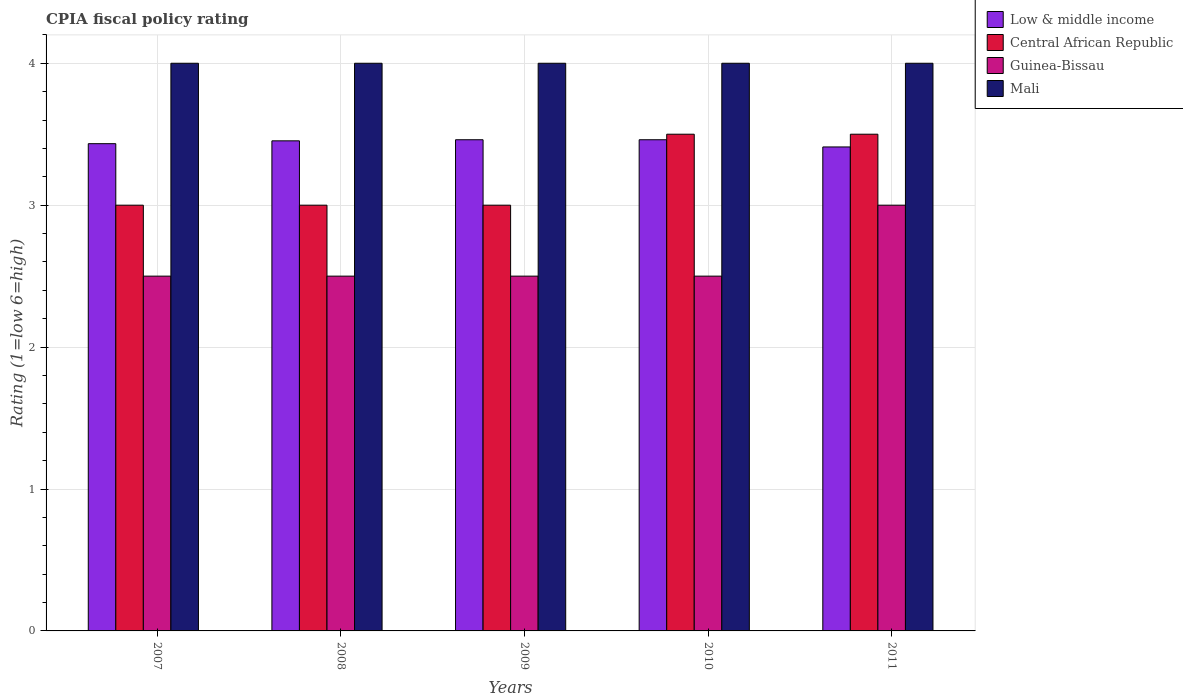How many different coloured bars are there?
Make the answer very short. 4. How many groups of bars are there?
Offer a terse response. 5. How many bars are there on the 4th tick from the left?
Offer a very short reply. 4. How many bars are there on the 2nd tick from the right?
Offer a terse response. 4. What is the CPIA rating in Mali in 2009?
Provide a succinct answer. 4. Across all years, what is the maximum CPIA rating in Mali?
Ensure brevity in your answer.  4. What is the total CPIA rating in Guinea-Bissau in the graph?
Provide a short and direct response. 13. What is the difference between the CPIA rating in Low & middle income in 2007 and that in 2008?
Ensure brevity in your answer.  -0.02. What is the difference between the CPIA rating in Guinea-Bissau in 2011 and the CPIA rating in Low & middle income in 2009?
Ensure brevity in your answer.  -0.46. What is the average CPIA rating in Guinea-Bissau per year?
Offer a very short reply. 2.6. In the year 2009, what is the difference between the CPIA rating in Low & middle income and CPIA rating in Central African Republic?
Ensure brevity in your answer.  0.46. In how many years, is the CPIA rating in Guinea-Bissau greater than 0.6000000000000001?
Ensure brevity in your answer.  5. What is the ratio of the CPIA rating in Central African Republic in 2009 to that in 2011?
Your answer should be compact. 0.86. Is the difference between the CPIA rating in Low & middle income in 2009 and 2010 greater than the difference between the CPIA rating in Central African Republic in 2009 and 2010?
Make the answer very short. Yes. In how many years, is the CPIA rating in Mali greater than the average CPIA rating in Mali taken over all years?
Your response must be concise. 0. Is the sum of the CPIA rating in Central African Republic in 2008 and 2011 greater than the maximum CPIA rating in Guinea-Bissau across all years?
Offer a terse response. Yes. Is it the case that in every year, the sum of the CPIA rating in Low & middle income and CPIA rating in Guinea-Bissau is greater than the sum of CPIA rating in Central African Republic and CPIA rating in Mali?
Provide a short and direct response. No. What does the 4th bar from the right in 2011 represents?
Give a very brief answer. Low & middle income. How many bars are there?
Provide a succinct answer. 20. Are all the bars in the graph horizontal?
Keep it short and to the point. No. How many years are there in the graph?
Keep it short and to the point. 5. Does the graph contain any zero values?
Provide a short and direct response. No. Does the graph contain grids?
Keep it short and to the point. Yes. Where does the legend appear in the graph?
Offer a terse response. Top right. What is the title of the graph?
Offer a terse response. CPIA fiscal policy rating. Does "Congo (Democratic)" appear as one of the legend labels in the graph?
Provide a succinct answer. No. What is the label or title of the Y-axis?
Make the answer very short. Rating (1=low 6=high). What is the Rating (1=low 6=high) of Low & middle income in 2007?
Ensure brevity in your answer.  3.43. What is the Rating (1=low 6=high) in Mali in 2007?
Your answer should be compact. 4. What is the Rating (1=low 6=high) of Low & middle income in 2008?
Your response must be concise. 3.45. What is the Rating (1=low 6=high) of Guinea-Bissau in 2008?
Keep it short and to the point. 2.5. What is the Rating (1=low 6=high) in Mali in 2008?
Provide a succinct answer. 4. What is the Rating (1=low 6=high) in Low & middle income in 2009?
Ensure brevity in your answer.  3.46. What is the Rating (1=low 6=high) in Central African Republic in 2009?
Make the answer very short. 3. What is the Rating (1=low 6=high) of Guinea-Bissau in 2009?
Your answer should be compact. 2.5. What is the Rating (1=low 6=high) of Low & middle income in 2010?
Provide a short and direct response. 3.46. What is the Rating (1=low 6=high) of Guinea-Bissau in 2010?
Your response must be concise. 2.5. What is the Rating (1=low 6=high) in Low & middle income in 2011?
Offer a very short reply. 3.41. Across all years, what is the maximum Rating (1=low 6=high) of Low & middle income?
Provide a short and direct response. 3.46. Across all years, what is the maximum Rating (1=low 6=high) in Guinea-Bissau?
Ensure brevity in your answer.  3. Across all years, what is the maximum Rating (1=low 6=high) of Mali?
Your response must be concise. 4. Across all years, what is the minimum Rating (1=low 6=high) of Low & middle income?
Ensure brevity in your answer.  3.41. Across all years, what is the minimum Rating (1=low 6=high) in Guinea-Bissau?
Your response must be concise. 2.5. What is the total Rating (1=low 6=high) of Low & middle income in the graph?
Your answer should be compact. 17.22. What is the total Rating (1=low 6=high) in Mali in the graph?
Provide a short and direct response. 20. What is the difference between the Rating (1=low 6=high) of Low & middle income in 2007 and that in 2008?
Provide a succinct answer. -0.02. What is the difference between the Rating (1=low 6=high) in Mali in 2007 and that in 2008?
Provide a short and direct response. 0. What is the difference between the Rating (1=low 6=high) of Low & middle income in 2007 and that in 2009?
Your answer should be compact. -0.03. What is the difference between the Rating (1=low 6=high) in Guinea-Bissau in 2007 and that in 2009?
Your answer should be compact. 0. What is the difference between the Rating (1=low 6=high) of Low & middle income in 2007 and that in 2010?
Make the answer very short. -0.03. What is the difference between the Rating (1=low 6=high) of Central African Republic in 2007 and that in 2010?
Your answer should be compact. -0.5. What is the difference between the Rating (1=low 6=high) of Mali in 2007 and that in 2010?
Your answer should be compact. 0. What is the difference between the Rating (1=low 6=high) of Low & middle income in 2007 and that in 2011?
Your answer should be compact. 0.02. What is the difference between the Rating (1=low 6=high) in Central African Republic in 2007 and that in 2011?
Ensure brevity in your answer.  -0.5. What is the difference between the Rating (1=low 6=high) of Guinea-Bissau in 2007 and that in 2011?
Keep it short and to the point. -0.5. What is the difference between the Rating (1=low 6=high) in Low & middle income in 2008 and that in 2009?
Provide a short and direct response. -0.01. What is the difference between the Rating (1=low 6=high) of Central African Republic in 2008 and that in 2009?
Offer a terse response. 0. What is the difference between the Rating (1=low 6=high) of Low & middle income in 2008 and that in 2010?
Offer a very short reply. -0.01. What is the difference between the Rating (1=low 6=high) of Central African Republic in 2008 and that in 2010?
Provide a short and direct response. -0.5. What is the difference between the Rating (1=low 6=high) in Guinea-Bissau in 2008 and that in 2010?
Make the answer very short. 0. What is the difference between the Rating (1=low 6=high) in Low & middle income in 2008 and that in 2011?
Keep it short and to the point. 0.04. What is the difference between the Rating (1=low 6=high) in Guinea-Bissau in 2008 and that in 2011?
Provide a succinct answer. -0.5. What is the difference between the Rating (1=low 6=high) in Central African Republic in 2009 and that in 2010?
Give a very brief answer. -0.5. What is the difference between the Rating (1=low 6=high) of Low & middle income in 2009 and that in 2011?
Offer a terse response. 0.05. What is the difference between the Rating (1=low 6=high) in Guinea-Bissau in 2009 and that in 2011?
Ensure brevity in your answer.  -0.5. What is the difference between the Rating (1=low 6=high) in Mali in 2009 and that in 2011?
Offer a very short reply. 0. What is the difference between the Rating (1=low 6=high) in Low & middle income in 2010 and that in 2011?
Provide a short and direct response. 0.05. What is the difference between the Rating (1=low 6=high) in Central African Republic in 2010 and that in 2011?
Your answer should be compact. 0. What is the difference between the Rating (1=low 6=high) of Guinea-Bissau in 2010 and that in 2011?
Your answer should be compact. -0.5. What is the difference between the Rating (1=low 6=high) of Low & middle income in 2007 and the Rating (1=low 6=high) of Central African Republic in 2008?
Your answer should be very brief. 0.43. What is the difference between the Rating (1=low 6=high) of Low & middle income in 2007 and the Rating (1=low 6=high) of Guinea-Bissau in 2008?
Keep it short and to the point. 0.93. What is the difference between the Rating (1=low 6=high) in Low & middle income in 2007 and the Rating (1=low 6=high) in Mali in 2008?
Your response must be concise. -0.57. What is the difference between the Rating (1=low 6=high) of Central African Republic in 2007 and the Rating (1=low 6=high) of Mali in 2008?
Provide a short and direct response. -1. What is the difference between the Rating (1=low 6=high) in Guinea-Bissau in 2007 and the Rating (1=low 6=high) in Mali in 2008?
Give a very brief answer. -1.5. What is the difference between the Rating (1=low 6=high) of Low & middle income in 2007 and the Rating (1=low 6=high) of Central African Republic in 2009?
Provide a short and direct response. 0.43. What is the difference between the Rating (1=low 6=high) in Low & middle income in 2007 and the Rating (1=low 6=high) in Mali in 2009?
Provide a short and direct response. -0.57. What is the difference between the Rating (1=low 6=high) in Central African Republic in 2007 and the Rating (1=low 6=high) in Mali in 2009?
Ensure brevity in your answer.  -1. What is the difference between the Rating (1=low 6=high) in Low & middle income in 2007 and the Rating (1=low 6=high) in Central African Republic in 2010?
Give a very brief answer. -0.07. What is the difference between the Rating (1=low 6=high) of Low & middle income in 2007 and the Rating (1=low 6=high) of Guinea-Bissau in 2010?
Your response must be concise. 0.93. What is the difference between the Rating (1=low 6=high) in Low & middle income in 2007 and the Rating (1=low 6=high) in Mali in 2010?
Your answer should be very brief. -0.57. What is the difference between the Rating (1=low 6=high) of Central African Republic in 2007 and the Rating (1=low 6=high) of Guinea-Bissau in 2010?
Provide a succinct answer. 0.5. What is the difference between the Rating (1=low 6=high) in Guinea-Bissau in 2007 and the Rating (1=low 6=high) in Mali in 2010?
Make the answer very short. -1.5. What is the difference between the Rating (1=low 6=high) in Low & middle income in 2007 and the Rating (1=low 6=high) in Central African Republic in 2011?
Make the answer very short. -0.07. What is the difference between the Rating (1=low 6=high) in Low & middle income in 2007 and the Rating (1=low 6=high) in Guinea-Bissau in 2011?
Your answer should be very brief. 0.43. What is the difference between the Rating (1=low 6=high) of Low & middle income in 2007 and the Rating (1=low 6=high) of Mali in 2011?
Provide a short and direct response. -0.57. What is the difference between the Rating (1=low 6=high) of Central African Republic in 2007 and the Rating (1=low 6=high) of Mali in 2011?
Ensure brevity in your answer.  -1. What is the difference between the Rating (1=low 6=high) in Guinea-Bissau in 2007 and the Rating (1=low 6=high) in Mali in 2011?
Make the answer very short. -1.5. What is the difference between the Rating (1=low 6=high) in Low & middle income in 2008 and the Rating (1=low 6=high) in Central African Republic in 2009?
Your answer should be compact. 0.45. What is the difference between the Rating (1=low 6=high) of Low & middle income in 2008 and the Rating (1=low 6=high) of Guinea-Bissau in 2009?
Your response must be concise. 0.95. What is the difference between the Rating (1=low 6=high) in Low & middle income in 2008 and the Rating (1=low 6=high) in Mali in 2009?
Provide a succinct answer. -0.55. What is the difference between the Rating (1=low 6=high) in Central African Republic in 2008 and the Rating (1=low 6=high) in Mali in 2009?
Ensure brevity in your answer.  -1. What is the difference between the Rating (1=low 6=high) in Guinea-Bissau in 2008 and the Rating (1=low 6=high) in Mali in 2009?
Your answer should be compact. -1.5. What is the difference between the Rating (1=low 6=high) of Low & middle income in 2008 and the Rating (1=low 6=high) of Central African Republic in 2010?
Offer a terse response. -0.05. What is the difference between the Rating (1=low 6=high) of Low & middle income in 2008 and the Rating (1=low 6=high) of Guinea-Bissau in 2010?
Ensure brevity in your answer.  0.95. What is the difference between the Rating (1=low 6=high) of Low & middle income in 2008 and the Rating (1=low 6=high) of Mali in 2010?
Give a very brief answer. -0.55. What is the difference between the Rating (1=low 6=high) in Guinea-Bissau in 2008 and the Rating (1=low 6=high) in Mali in 2010?
Your answer should be very brief. -1.5. What is the difference between the Rating (1=low 6=high) in Low & middle income in 2008 and the Rating (1=low 6=high) in Central African Republic in 2011?
Keep it short and to the point. -0.05. What is the difference between the Rating (1=low 6=high) of Low & middle income in 2008 and the Rating (1=low 6=high) of Guinea-Bissau in 2011?
Ensure brevity in your answer.  0.45. What is the difference between the Rating (1=low 6=high) of Low & middle income in 2008 and the Rating (1=low 6=high) of Mali in 2011?
Provide a short and direct response. -0.55. What is the difference between the Rating (1=low 6=high) of Central African Republic in 2008 and the Rating (1=low 6=high) of Mali in 2011?
Your answer should be very brief. -1. What is the difference between the Rating (1=low 6=high) of Guinea-Bissau in 2008 and the Rating (1=low 6=high) of Mali in 2011?
Provide a short and direct response. -1.5. What is the difference between the Rating (1=low 6=high) in Low & middle income in 2009 and the Rating (1=low 6=high) in Central African Republic in 2010?
Your answer should be very brief. -0.04. What is the difference between the Rating (1=low 6=high) of Low & middle income in 2009 and the Rating (1=low 6=high) of Guinea-Bissau in 2010?
Your answer should be very brief. 0.96. What is the difference between the Rating (1=low 6=high) in Low & middle income in 2009 and the Rating (1=low 6=high) in Mali in 2010?
Your response must be concise. -0.54. What is the difference between the Rating (1=low 6=high) of Central African Republic in 2009 and the Rating (1=low 6=high) of Guinea-Bissau in 2010?
Provide a short and direct response. 0.5. What is the difference between the Rating (1=low 6=high) in Central African Republic in 2009 and the Rating (1=low 6=high) in Mali in 2010?
Offer a very short reply. -1. What is the difference between the Rating (1=low 6=high) of Guinea-Bissau in 2009 and the Rating (1=low 6=high) of Mali in 2010?
Give a very brief answer. -1.5. What is the difference between the Rating (1=low 6=high) in Low & middle income in 2009 and the Rating (1=low 6=high) in Central African Republic in 2011?
Give a very brief answer. -0.04. What is the difference between the Rating (1=low 6=high) in Low & middle income in 2009 and the Rating (1=low 6=high) in Guinea-Bissau in 2011?
Offer a very short reply. 0.46. What is the difference between the Rating (1=low 6=high) of Low & middle income in 2009 and the Rating (1=low 6=high) of Mali in 2011?
Provide a succinct answer. -0.54. What is the difference between the Rating (1=low 6=high) in Central African Republic in 2009 and the Rating (1=low 6=high) in Mali in 2011?
Ensure brevity in your answer.  -1. What is the difference between the Rating (1=low 6=high) of Guinea-Bissau in 2009 and the Rating (1=low 6=high) of Mali in 2011?
Make the answer very short. -1.5. What is the difference between the Rating (1=low 6=high) of Low & middle income in 2010 and the Rating (1=low 6=high) of Central African Republic in 2011?
Offer a terse response. -0.04. What is the difference between the Rating (1=low 6=high) in Low & middle income in 2010 and the Rating (1=low 6=high) in Guinea-Bissau in 2011?
Your answer should be compact. 0.46. What is the difference between the Rating (1=low 6=high) of Low & middle income in 2010 and the Rating (1=low 6=high) of Mali in 2011?
Your response must be concise. -0.54. What is the difference between the Rating (1=low 6=high) in Central African Republic in 2010 and the Rating (1=low 6=high) in Guinea-Bissau in 2011?
Provide a short and direct response. 0.5. What is the difference between the Rating (1=low 6=high) in Central African Republic in 2010 and the Rating (1=low 6=high) in Mali in 2011?
Your response must be concise. -0.5. What is the difference between the Rating (1=low 6=high) of Guinea-Bissau in 2010 and the Rating (1=low 6=high) of Mali in 2011?
Your response must be concise. -1.5. What is the average Rating (1=low 6=high) of Low & middle income per year?
Give a very brief answer. 3.44. What is the average Rating (1=low 6=high) of Central African Republic per year?
Provide a succinct answer. 3.2. What is the average Rating (1=low 6=high) in Mali per year?
Provide a short and direct response. 4. In the year 2007, what is the difference between the Rating (1=low 6=high) of Low & middle income and Rating (1=low 6=high) of Central African Republic?
Give a very brief answer. 0.43. In the year 2007, what is the difference between the Rating (1=low 6=high) of Low & middle income and Rating (1=low 6=high) of Mali?
Offer a terse response. -0.57. In the year 2007, what is the difference between the Rating (1=low 6=high) of Guinea-Bissau and Rating (1=low 6=high) of Mali?
Ensure brevity in your answer.  -1.5. In the year 2008, what is the difference between the Rating (1=low 6=high) in Low & middle income and Rating (1=low 6=high) in Central African Republic?
Provide a succinct answer. 0.45. In the year 2008, what is the difference between the Rating (1=low 6=high) in Low & middle income and Rating (1=low 6=high) in Guinea-Bissau?
Ensure brevity in your answer.  0.95. In the year 2008, what is the difference between the Rating (1=low 6=high) of Low & middle income and Rating (1=low 6=high) of Mali?
Provide a short and direct response. -0.55. In the year 2008, what is the difference between the Rating (1=low 6=high) in Guinea-Bissau and Rating (1=low 6=high) in Mali?
Make the answer very short. -1.5. In the year 2009, what is the difference between the Rating (1=low 6=high) in Low & middle income and Rating (1=low 6=high) in Central African Republic?
Offer a very short reply. 0.46. In the year 2009, what is the difference between the Rating (1=low 6=high) of Low & middle income and Rating (1=low 6=high) of Mali?
Make the answer very short. -0.54. In the year 2009, what is the difference between the Rating (1=low 6=high) of Central African Republic and Rating (1=low 6=high) of Guinea-Bissau?
Provide a short and direct response. 0.5. In the year 2009, what is the difference between the Rating (1=low 6=high) of Central African Republic and Rating (1=low 6=high) of Mali?
Make the answer very short. -1. In the year 2009, what is the difference between the Rating (1=low 6=high) in Guinea-Bissau and Rating (1=low 6=high) in Mali?
Offer a terse response. -1.5. In the year 2010, what is the difference between the Rating (1=low 6=high) of Low & middle income and Rating (1=low 6=high) of Central African Republic?
Keep it short and to the point. -0.04. In the year 2010, what is the difference between the Rating (1=low 6=high) of Low & middle income and Rating (1=low 6=high) of Mali?
Give a very brief answer. -0.54. In the year 2010, what is the difference between the Rating (1=low 6=high) in Central African Republic and Rating (1=low 6=high) in Guinea-Bissau?
Your answer should be compact. 1. In the year 2010, what is the difference between the Rating (1=low 6=high) in Guinea-Bissau and Rating (1=low 6=high) in Mali?
Ensure brevity in your answer.  -1.5. In the year 2011, what is the difference between the Rating (1=low 6=high) of Low & middle income and Rating (1=low 6=high) of Central African Republic?
Your answer should be very brief. -0.09. In the year 2011, what is the difference between the Rating (1=low 6=high) of Low & middle income and Rating (1=low 6=high) of Guinea-Bissau?
Give a very brief answer. 0.41. In the year 2011, what is the difference between the Rating (1=low 6=high) in Low & middle income and Rating (1=low 6=high) in Mali?
Give a very brief answer. -0.59. In the year 2011, what is the difference between the Rating (1=low 6=high) of Central African Republic and Rating (1=low 6=high) of Guinea-Bissau?
Your response must be concise. 0.5. In the year 2011, what is the difference between the Rating (1=low 6=high) in Guinea-Bissau and Rating (1=low 6=high) in Mali?
Your response must be concise. -1. What is the ratio of the Rating (1=low 6=high) of Low & middle income in 2007 to that in 2008?
Give a very brief answer. 0.99. What is the ratio of the Rating (1=low 6=high) in Guinea-Bissau in 2007 to that in 2008?
Offer a very short reply. 1. What is the ratio of the Rating (1=low 6=high) in Mali in 2007 to that in 2008?
Provide a succinct answer. 1. What is the ratio of the Rating (1=low 6=high) in Low & middle income in 2007 to that in 2010?
Provide a short and direct response. 0.99. What is the ratio of the Rating (1=low 6=high) of Central African Republic in 2007 to that in 2010?
Offer a very short reply. 0.86. What is the ratio of the Rating (1=low 6=high) of Mali in 2007 to that in 2010?
Provide a short and direct response. 1. What is the ratio of the Rating (1=low 6=high) in Low & middle income in 2007 to that in 2011?
Offer a terse response. 1.01. What is the ratio of the Rating (1=low 6=high) of Central African Republic in 2007 to that in 2011?
Provide a short and direct response. 0.86. What is the ratio of the Rating (1=low 6=high) of Guinea-Bissau in 2007 to that in 2011?
Ensure brevity in your answer.  0.83. What is the ratio of the Rating (1=low 6=high) in Central African Republic in 2008 to that in 2009?
Make the answer very short. 1. What is the ratio of the Rating (1=low 6=high) in Low & middle income in 2008 to that in 2010?
Provide a short and direct response. 1. What is the ratio of the Rating (1=low 6=high) in Mali in 2008 to that in 2010?
Give a very brief answer. 1. What is the ratio of the Rating (1=low 6=high) in Low & middle income in 2008 to that in 2011?
Provide a succinct answer. 1.01. What is the ratio of the Rating (1=low 6=high) of Central African Republic in 2008 to that in 2011?
Your answer should be compact. 0.86. What is the ratio of the Rating (1=low 6=high) in Guinea-Bissau in 2008 to that in 2011?
Offer a terse response. 0.83. What is the ratio of the Rating (1=low 6=high) of Mali in 2008 to that in 2011?
Your answer should be compact. 1. What is the ratio of the Rating (1=low 6=high) in Central African Republic in 2009 to that in 2010?
Your answer should be very brief. 0.86. What is the ratio of the Rating (1=low 6=high) of Guinea-Bissau in 2009 to that in 2010?
Provide a succinct answer. 1. What is the ratio of the Rating (1=low 6=high) of Mali in 2009 to that in 2010?
Provide a short and direct response. 1. What is the ratio of the Rating (1=low 6=high) in Low & middle income in 2009 to that in 2011?
Make the answer very short. 1.01. What is the ratio of the Rating (1=low 6=high) of Central African Republic in 2009 to that in 2011?
Give a very brief answer. 0.86. What is the ratio of the Rating (1=low 6=high) in Low & middle income in 2010 to that in 2011?
Give a very brief answer. 1.01. What is the difference between the highest and the second highest Rating (1=low 6=high) of Central African Republic?
Give a very brief answer. 0. What is the difference between the highest and the second highest Rating (1=low 6=high) of Mali?
Ensure brevity in your answer.  0. What is the difference between the highest and the lowest Rating (1=low 6=high) in Low & middle income?
Offer a terse response. 0.05. What is the difference between the highest and the lowest Rating (1=low 6=high) of Mali?
Offer a terse response. 0. 